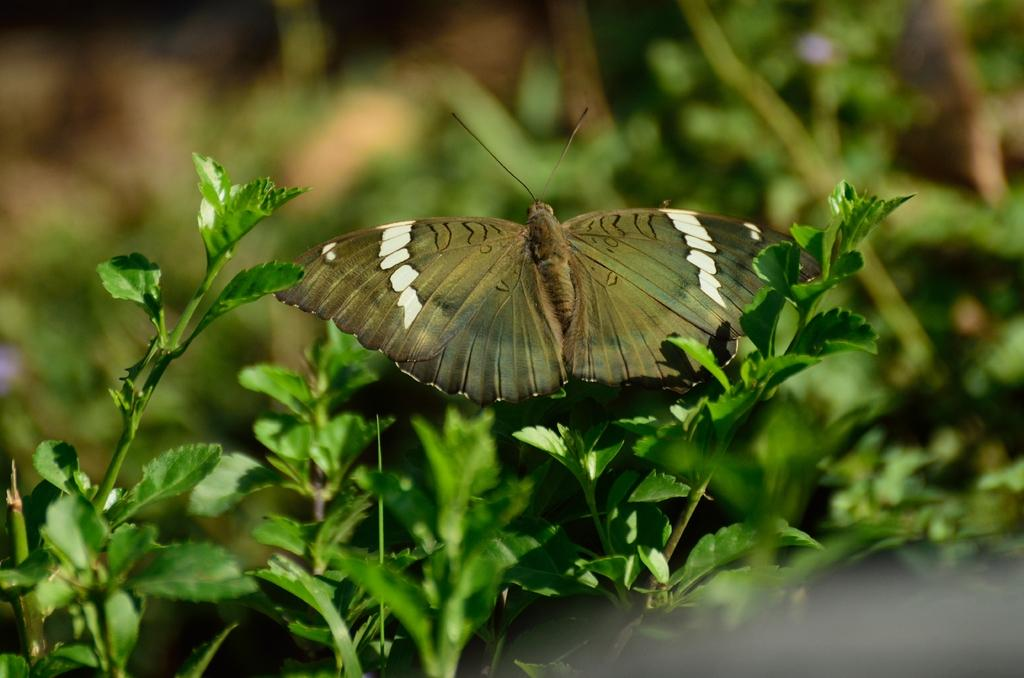What type of creature is in the image? There is a butterfly in the image. Where is the butterfly located in relation to other objects in the image? The butterfly is near to the plants. What type of vegetation can be seen in the image? There are leaves visible in the image. What type of building can be seen in the background of the image? There is no building present in the image; it features a butterfly near plants with visible leaves. 